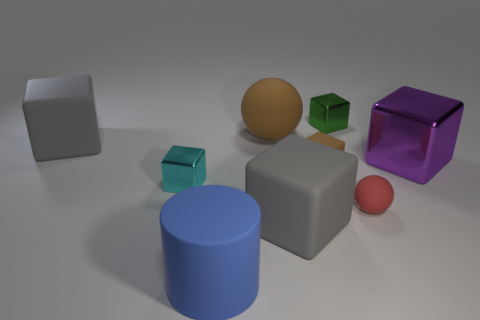Subtract all big purple cubes. How many cubes are left? 5 Subtract all cyan cylinders. How many gray blocks are left? 2 Subtract all green blocks. How many blocks are left? 5 Subtract 4 cubes. How many cubes are left? 2 Add 1 rubber cubes. How many objects exist? 10 Subtract all yellow cubes. Subtract all yellow balls. How many cubes are left? 6 Subtract all tiny brown matte cubes. Subtract all rubber objects. How many objects are left? 2 Add 2 large metallic things. How many large metallic things are left? 3 Add 6 purple rubber balls. How many purple rubber balls exist? 6 Subtract 0 cyan cylinders. How many objects are left? 9 